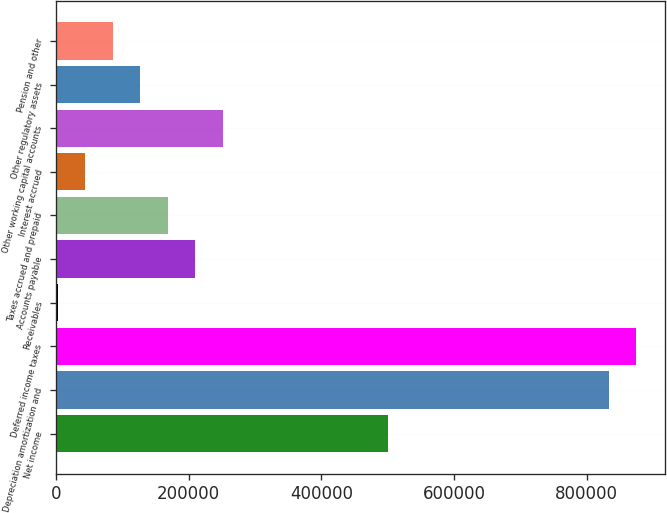<chart> <loc_0><loc_0><loc_500><loc_500><bar_chart><fcel>Net income<fcel>Depreciation amortization and<fcel>Deferred income taxes<fcel>Receivables<fcel>Accounts payable<fcel>Taxes accrued and prepaid<fcel>Interest accrued<fcel>Other working capital accounts<fcel>Other regulatory assets<fcel>Pension and other<nl><fcel>500993<fcel>833458<fcel>875016<fcel>2296<fcel>210086<fcel>168528<fcel>43854.1<fcel>251645<fcel>126970<fcel>85412.2<nl></chart> 